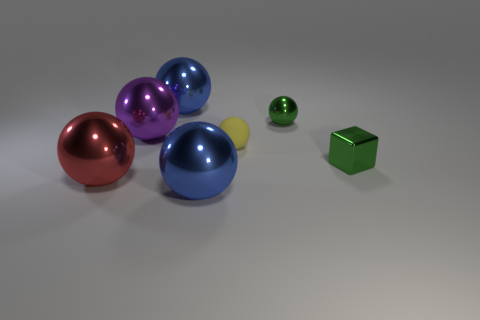Subtract 3 balls. How many balls are left? 3 Subtract all purple balls. How many balls are left? 5 Subtract all yellow spheres. How many spheres are left? 5 Subtract all green spheres. Subtract all blue blocks. How many spheres are left? 5 Add 1 tiny yellow matte things. How many objects exist? 8 Subtract all spheres. How many objects are left? 1 Subtract all purple things. Subtract all small metallic things. How many objects are left? 4 Add 5 large blue shiny balls. How many large blue shiny balls are left? 7 Add 5 small green metallic blocks. How many small green metallic blocks exist? 6 Subtract 0 purple blocks. How many objects are left? 7 